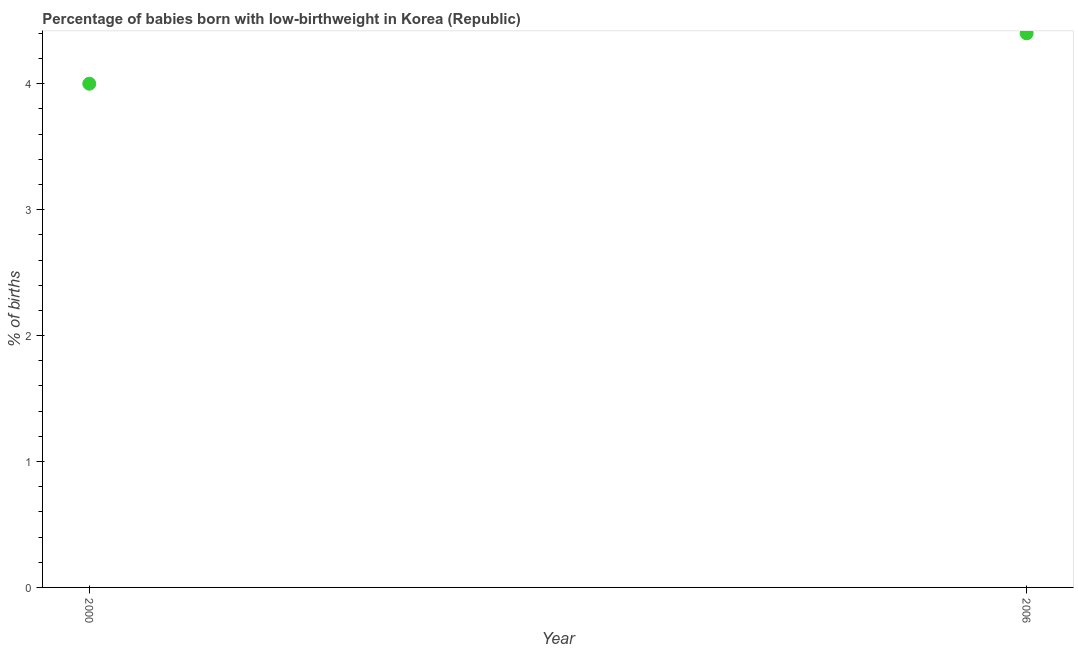In which year was the percentage of babies who were born with low-birthweight maximum?
Your answer should be compact. 2006. In which year was the percentage of babies who were born with low-birthweight minimum?
Give a very brief answer. 2000. What is the sum of the percentage of babies who were born with low-birthweight?
Your response must be concise. 8.4. What is the difference between the percentage of babies who were born with low-birthweight in 2000 and 2006?
Provide a succinct answer. -0.4. In how many years, is the percentage of babies who were born with low-birthweight greater than 1.2 %?
Offer a terse response. 2. What is the ratio of the percentage of babies who were born with low-birthweight in 2000 to that in 2006?
Make the answer very short. 0.91. Is the percentage of babies who were born with low-birthweight in 2000 less than that in 2006?
Give a very brief answer. Yes. In how many years, is the percentage of babies who were born with low-birthweight greater than the average percentage of babies who were born with low-birthweight taken over all years?
Keep it short and to the point. 1. How many dotlines are there?
Offer a very short reply. 1. What is the difference between two consecutive major ticks on the Y-axis?
Offer a terse response. 1. Are the values on the major ticks of Y-axis written in scientific E-notation?
Give a very brief answer. No. Does the graph contain grids?
Your answer should be very brief. No. What is the title of the graph?
Your answer should be very brief. Percentage of babies born with low-birthweight in Korea (Republic). What is the label or title of the X-axis?
Provide a succinct answer. Year. What is the label or title of the Y-axis?
Make the answer very short. % of births. What is the % of births in 2000?
Your response must be concise. 4. What is the ratio of the % of births in 2000 to that in 2006?
Keep it short and to the point. 0.91. 